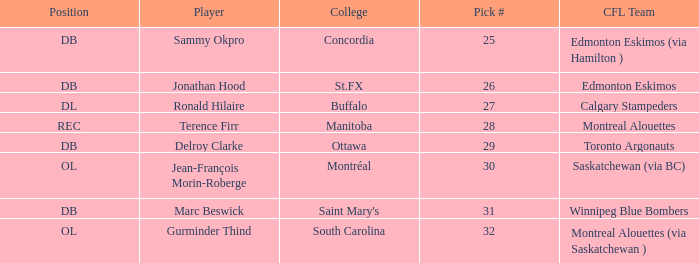Which CFL Team has a Pick # larger than 31? Montreal Alouettes (via Saskatchewan ). 